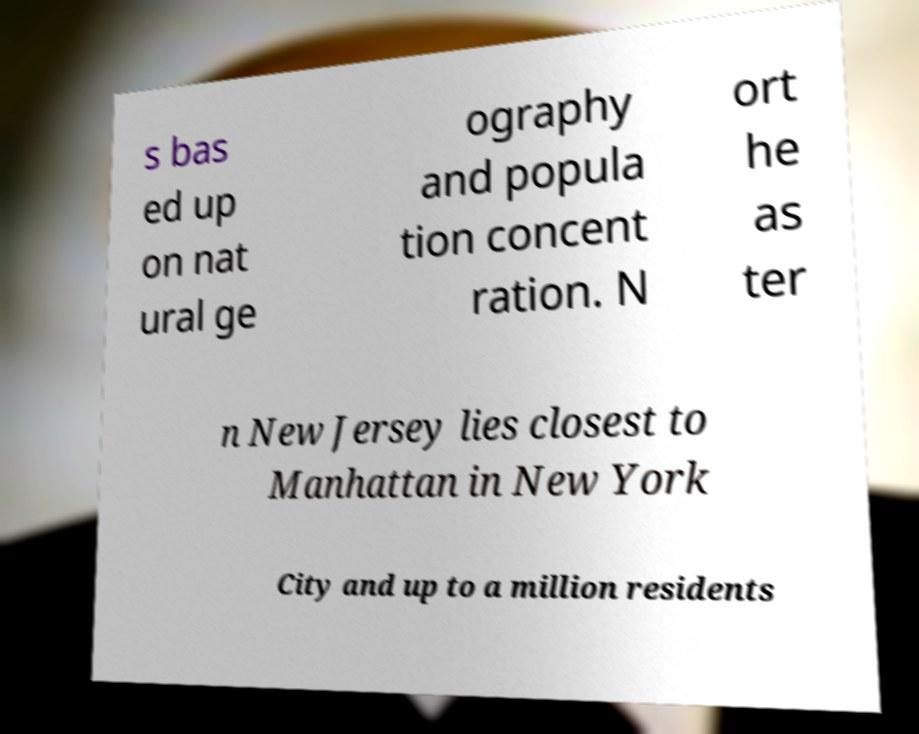Can you accurately transcribe the text from the provided image for me? s bas ed up on nat ural ge ography and popula tion concent ration. N ort he as ter n New Jersey lies closest to Manhattan in New York City and up to a million residents 